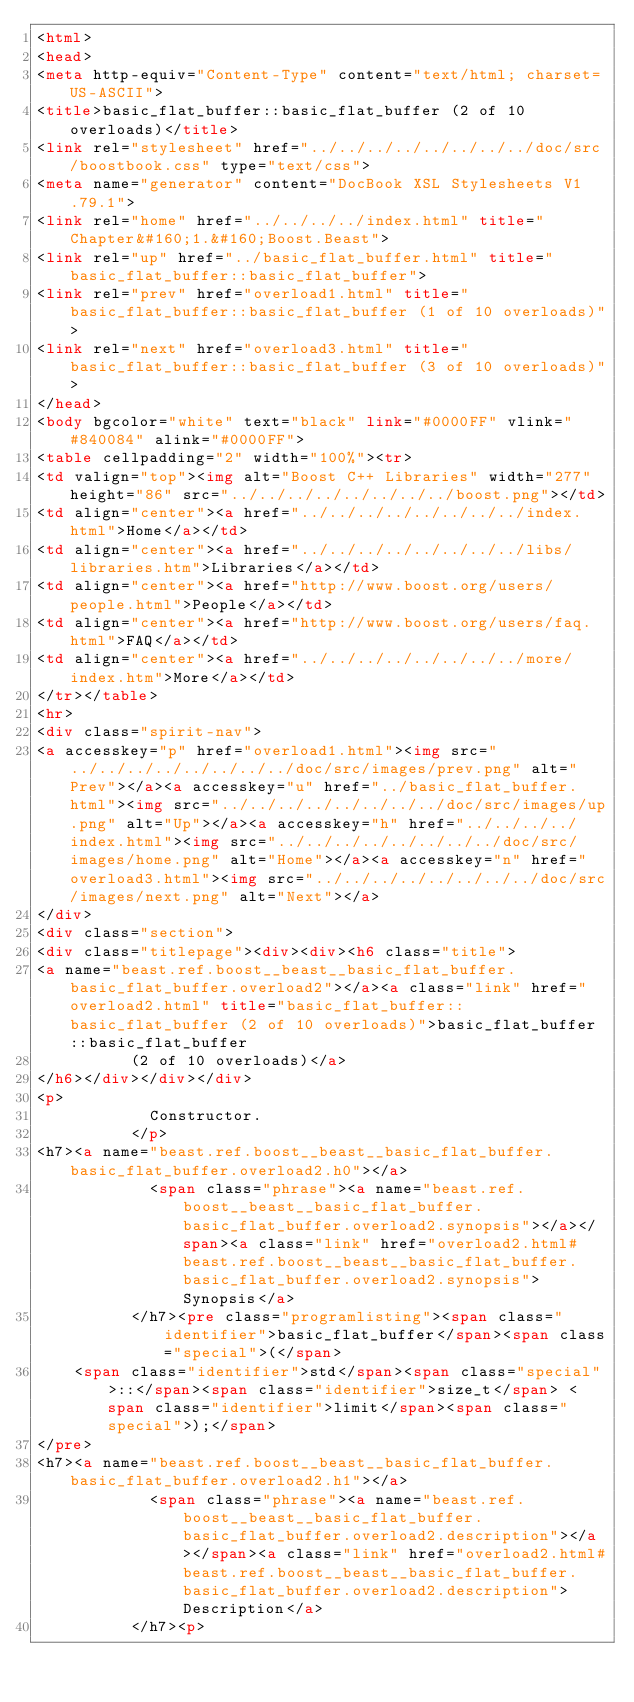<code> <loc_0><loc_0><loc_500><loc_500><_HTML_><html>
<head>
<meta http-equiv="Content-Type" content="text/html; charset=US-ASCII">
<title>basic_flat_buffer::basic_flat_buffer (2 of 10 overloads)</title>
<link rel="stylesheet" href="../../../../../../../../doc/src/boostbook.css" type="text/css">
<meta name="generator" content="DocBook XSL Stylesheets V1.79.1">
<link rel="home" href="../../../../index.html" title="Chapter&#160;1.&#160;Boost.Beast">
<link rel="up" href="../basic_flat_buffer.html" title="basic_flat_buffer::basic_flat_buffer">
<link rel="prev" href="overload1.html" title="basic_flat_buffer::basic_flat_buffer (1 of 10 overloads)">
<link rel="next" href="overload3.html" title="basic_flat_buffer::basic_flat_buffer (3 of 10 overloads)">
</head>
<body bgcolor="white" text="black" link="#0000FF" vlink="#840084" alink="#0000FF">
<table cellpadding="2" width="100%"><tr>
<td valign="top"><img alt="Boost C++ Libraries" width="277" height="86" src="../../../../../../../../boost.png"></td>
<td align="center"><a href="../../../../../../../../index.html">Home</a></td>
<td align="center"><a href="../../../../../../../../libs/libraries.htm">Libraries</a></td>
<td align="center"><a href="http://www.boost.org/users/people.html">People</a></td>
<td align="center"><a href="http://www.boost.org/users/faq.html">FAQ</a></td>
<td align="center"><a href="../../../../../../../../more/index.htm">More</a></td>
</tr></table>
<hr>
<div class="spirit-nav">
<a accesskey="p" href="overload1.html"><img src="../../../../../../../../doc/src/images/prev.png" alt="Prev"></a><a accesskey="u" href="../basic_flat_buffer.html"><img src="../../../../../../../../doc/src/images/up.png" alt="Up"></a><a accesskey="h" href="../../../../index.html"><img src="../../../../../../../../doc/src/images/home.png" alt="Home"></a><a accesskey="n" href="overload3.html"><img src="../../../../../../../../doc/src/images/next.png" alt="Next"></a>
</div>
<div class="section">
<div class="titlepage"><div><div><h6 class="title">
<a name="beast.ref.boost__beast__basic_flat_buffer.basic_flat_buffer.overload2"></a><a class="link" href="overload2.html" title="basic_flat_buffer::basic_flat_buffer (2 of 10 overloads)">basic_flat_buffer::basic_flat_buffer
          (2 of 10 overloads)</a>
</h6></div></div></div>
<p>
            Constructor.
          </p>
<h7><a name="beast.ref.boost__beast__basic_flat_buffer.basic_flat_buffer.overload2.h0"></a>
            <span class="phrase"><a name="beast.ref.boost__beast__basic_flat_buffer.basic_flat_buffer.overload2.synopsis"></a></span><a class="link" href="overload2.html#beast.ref.boost__beast__basic_flat_buffer.basic_flat_buffer.overload2.synopsis">Synopsis</a>
          </h7><pre class="programlisting"><span class="identifier">basic_flat_buffer</span><span class="special">(</span>
    <span class="identifier">std</span><span class="special">::</span><span class="identifier">size_t</span> <span class="identifier">limit</span><span class="special">);</span>
</pre>
<h7><a name="beast.ref.boost__beast__basic_flat_buffer.basic_flat_buffer.overload2.h1"></a>
            <span class="phrase"><a name="beast.ref.boost__beast__basic_flat_buffer.basic_flat_buffer.overload2.description"></a></span><a class="link" href="overload2.html#beast.ref.boost__beast__basic_flat_buffer.basic_flat_buffer.overload2.description">Description</a>
          </h7><p></code> 